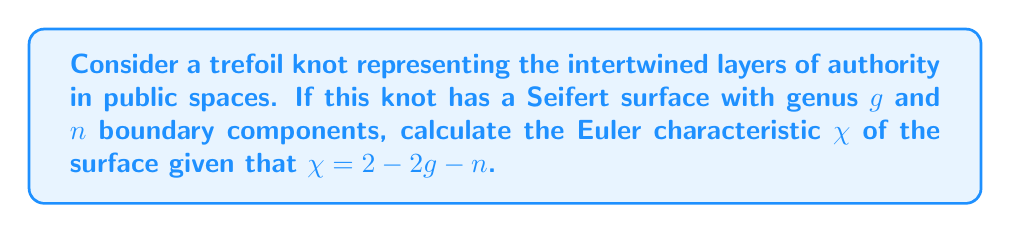Give your solution to this math problem. Let's approach this step-by-step:

1) The trefoil knot is one of the simplest non-trivial knots, making it an apt symbol for the complex yet fundamental nature of authority in public spaces.

2) For a trefoil knot:
   - The minimal genus of a Seifert surface is $g = 1$
   - The number of boundary components is always $n = 1$ for any knot

3) We are given the formula for the Euler characteristic:
   $$\chi = 2 - 2g - n$$

4) Let's substitute the known values:
   $$\chi = 2 - 2(1) - 1$$

5) Simplify:
   $$\chi = 2 - 2 - 1 = -1$$

The negative Euler characteristic could be interpreted as representing the potentially divisive nature of authority in public spaces, aligning with the persona's perspective on over-policing.
Answer: $\chi = -1$ 